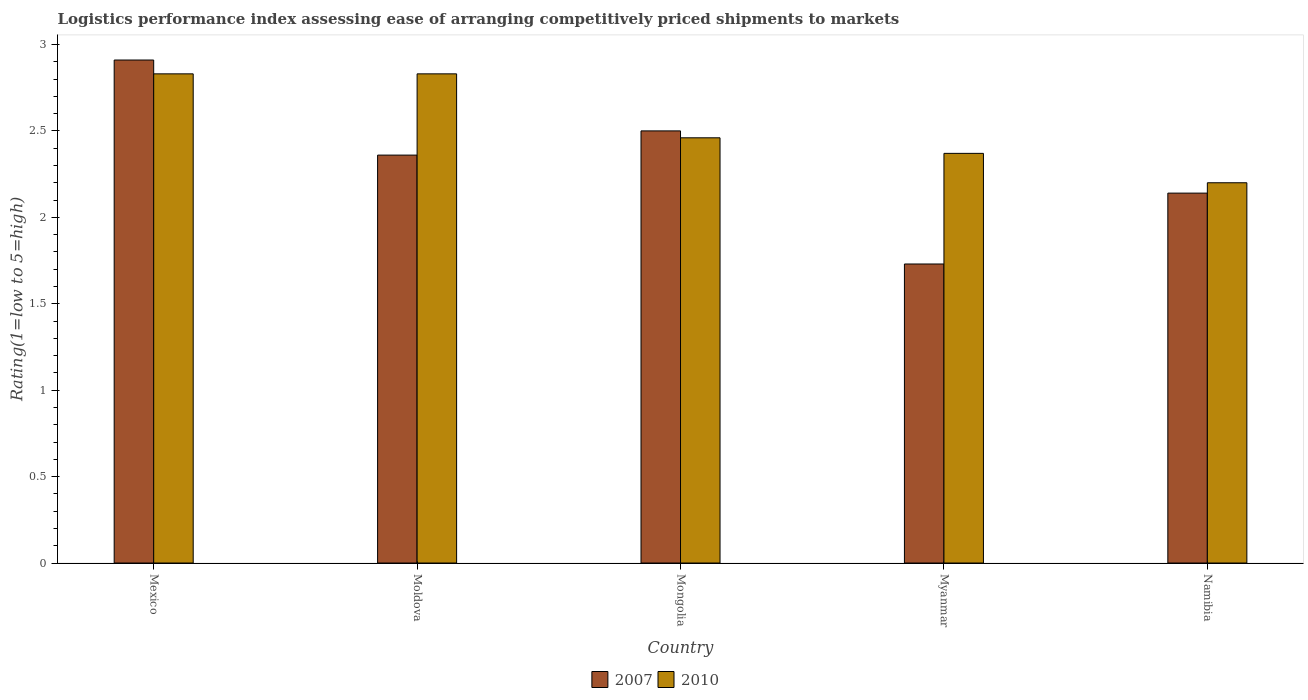How many groups of bars are there?
Give a very brief answer. 5. Are the number of bars per tick equal to the number of legend labels?
Your response must be concise. Yes. What is the label of the 4th group of bars from the left?
Your answer should be very brief. Myanmar. In how many cases, is the number of bars for a given country not equal to the number of legend labels?
Ensure brevity in your answer.  0. Across all countries, what is the maximum Logistic performance index in 2007?
Ensure brevity in your answer.  2.91. Across all countries, what is the minimum Logistic performance index in 2007?
Make the answer very short. 1.73. In which country was the Logistic performance index in 2010 minimum?
Provide a short and direct response. Namibia. What is the total Logistic performance index in 2007 in the graph?
Offer a very short reply. 11.64. What is the difference between the Logistic performance index in 2010 in Mongolia and that in Myanmar?
Keep it short and to the point. 0.09. What is the difference between the Logistic performance index in 2007 in Moldova and the Logistic performance index in 2010 in Namibia?
Ensure brevity in your answer.  0.16. What is the average Logistic performance index in 2007 per country?
Make the answer very short. 2.33. What is the difference between the Logistic performance index of/in 2010 and Logistic performance index of/in 2007 in Mongolia?
Keep it short and to the point. -0.04. In how many countries, is the Logistic performance index in 2010 greater than 2.2?
Keep it short and to the point. 4. What is the ratio of the Logistic performance index in 2007 in Moldova to that in Mongolia?
Give a very brief answer. 0.94. What is the difference between the highest and the second highest Logistic performance index in 2010?
Your response must be concise. 0.37. What is the difference between the highest and the lowest Logistic performance index in 2010?
Make the answer very short. 0.63. In how many countries, is the Logistic performance index in 2010 greater than the average Logistic performance index in 2010 taken over all countries?
Offer a terse response. 2. Is the sum of the Logistic performance index in 2007 in Mexico and Myanmar greater than the maximum Logistic performance index in 2010 across all countries?
Offer a very short reply. Yes. What does the 2nd bar from the right in Mexico represents?
Give a very brief answer. 2007. How many bars are there?
Offer a very short reply. 10. Are all the bars in the graph horizontal?
Make the answer very short. No. How many countries are there in the graph?
Provide a succinct answer. 5. Does the graph contain any zero values?
Your response must be concise. No. How many legend labels are there?
Your response must be concise. 2. How are the legend labels stacked?
Your response must be concise. Horizontal. What is the title of the graph?
Provide a succinct answer. Logistics performance index assessing ease of arranging competitively priced shipments to markets. Does "2008" appear as one of the legend labels in the graph?
Your answer should be very brief. No. What is the label or title of the X-axis?
Your answer should be compact. Country. What is the label or title of the Y-axis?
Ensure brevity in your answer.  Rating(1=low to 5=high). What is the Rating(1=low to 5=high) of 2007 in Mexico?
Make the answer very short. 2.91. What is the Rating(1=low to 5=high) in 2010 in Mexico?
Offer a very short reply. 2.83. What is the Rating(1=low to 5=high) of 2007 in Moldova?
Your answer should be compact. 2.36. What is the Rating(1=low to 5=high) in 2010 in Moldova?
Ensure brevity in your answer.  2.83. What is the Rating(1=low to 5=high) of 2007 in Mongolia?
Give a very brief answer. 2.5. What is the Rating(1=low to 5=high) of 2010 in Mongolia?
Make the answer very short. 2.46. What is the Rating(1=low to 5=high) in 2007 in Myanmar?
Offer a very short reply. 1.73. What is the Rating(1=low to 5=high) in 2010 in Myanmar?
Offer a very short reply. 2.37. What is the Rating(1=low to 5=high) of 2007 in Namibia?
Your response must be concise. 2.14. What is the Rating(1=low to 5=high) in 2010 in Namibia?
Give a very brief answer. 2.2. Across all countries, what is the maximum Rating(1=low to 5=high) of 2007?
Provide a short and direct response. 2.91. Across all countries, what is the maximum Rating(1=low to 5=high) of 2010?
Offer a very short reply. 2.83. Across all countries, what is the minimum Rating(1=low to 5=high) of 2007?
Ensure brevity in your answer.  1.73. What is the total Rating(1=low to 5=high) of 2007 in the graph?
Provide a short and direct response. 11.64. What is the total Rating(1=low to 5=high) of 2010 in the graph?
Offer a very short reply. 12.69. What is the difference between the Rating(1=low to 5=high) of 2007 in Mexico and that in Moldova?
Your answer should be compact. 0.55. What is the difference between the Rating(1=low to 5=high) of 2010 in Mexico and that in Moldova?
Offer a very short reply. 0. What is the difference between the Rating(1=low to 5=high) of 2007 in Mexico and that in Mongolia?
Make the answer very short. 0.41. What is the difference between the Rating(1=low to 5=high) of 2010 in Mexico and that in Mongolia?
Offer a terse response. 0.37. What is the difference between the Rating(1=low to 5=high) of 2007 in Mexico and that in Myanmar?
Offer a terse response. 1.18. What is the difference between the Rating(1=low to 5=high) in 2010 in Mexico and that in Myanmar?
Keep it short and to the point. 0.46. What is the difference between the Rating(1=low to 5=high) in 2007 in Mexico and that in Namibia?
Ensure brevity in your answer.  0.77. What is the difference between the Rating(1=low to 5=high) in 2010 in Mexico and that in Namibia?
Ensure brevity in your answer.  0.63. What is the difference between the Rating(1=low to 5=high) in 2007 in Moldova and that in Mongolia?
Offer a terse response. -0.14. What is the difference between the Rating(1=low to 5=high) in 2010 in Moldova and that in Mongolia?
Keep it short and to the point. 0.37. What is the difference between the Rating(1=low to 5=high) of 2007 in Moldova and that in Myanmar?
Your response must be concise. 0.63. What is the difference between the Rating(1=low to 5=high) in 2010 in Moldova and that in Myanmar?
Provide a succinct answer. 0.46. What is the difference between the Rating(1=low to 5=high) of 2007 in Moldova and that in Namibia?
Your answer should be compact. 0.22. What is the difference between the Rating(1=low to 5=high) of 2010 in Moldova and that in Namibia?
Your answer should be compact. 0.63. What is the difference between the Rating(1=low to 5=high) in 2007 in Mongolia and that in Myanmar?
Ensure brevity in your answer.  0.77. What is the difference between the Rating(1=low to 5=high) of 2010 in Mongolia and that in Myanmar?
Your answer should be very brief. 0.09. What is the difference between the Rating(1=low to 5=high) of 2007 in Mongolia and that in Namibia?
Your answer should be compact. 0.36. What is the difference between the Rating(1=low to 5=high) of 2010 in Mongolia and that in Namibia?
Give a very brief answer. 0.26. What is the difference between the Rating(1=low to 5=high) in 2007 in Myanmar and that in Namibia?
Your answer should be compact. -0.41. What is the difference between the Rating(1=low to 5=high) in 2010 in Myanmar and that in Namibia?
Provide a short and direct response. 0.17. What is the difference between the Rating(1=low to 5=high) in 2007 in Mexico and the Rating(1=low to 5=high) in 2010 in Moldova?
Give a very brief answer. 0.08. What is the difference between the Rating(1=low to 5=high) in 2007 in Mexico and the Rating(1=low to 5=high) in 2010 in Mongolia?
Your answer should be very brief. 0.45. What is the difference between the Rating(1=low to 5=high) of 2007 in Mexico and the Rating(1=low to 5=high) of 2010 in Myanmar?
Keep it short and to the point. 0.54. What is the difference between the Rating(1=low to 5=high) in 2007 in Mexico and the Rating(1=low to 5=high) in 2010 in Namibia?
Give a very brief answer. 0.71. What is the difference between the Rating(1=low to 5=high) of 2007 in Moldova and the Rating(1=low to 5=high) of 2010 in Mongolia?
Your answer should be very brief. -0.1. What is the difference between the Rating(1=low to 5=high) in 2007 in Moldova and the Rating(1=low to 5=high) in 2010 in Myanmar?
Make the answer very short. -0.01. What is the difference between the Rating(1=low to 5=high) of 2007 in Moldova and the Rating(1=low to 5=high) of 2010 in Namibia?
Keep it short and to the point. 0.16. What is the difference between the Rating(1=low to 5=high) in 2007 in Mongolia and the Rating(1=low to 5=high) in 2010 in Myanmar?
Provide a succinct answer. 0.13. What is the difference between the Rating(1=low to 5=high) in 2007 in Mongolia and the Rating(1=low to 5=high) in 2010 in Namibia?
Ensure brevity in your answer.  0.3. What is the difference between the Rating(1=low to 5=high) in 2007 in Myanmar and the Rating(1=low to 5=high) in 2010 in Namibia?
Ensure brevity in your answer.  -0.47. What is the average Rating(1=low to 5=high) in 2007 per country?
Your answer should be compact. 2.33. What is the average Rating(1=low to 5=high) in 2010 per country?
Provide a succinct answer. 2.54. What is the difference between the Rating(1=low to 5=high) of 2007 and Rating(1=low to 5=high) of 2010 in Mexico?
Give a very brief answer. 0.08. What is the difference between the Rating(1=low to 5=high) in 2007 and Rating(1=low to 5=high) in 2010 in Moldova?
Provide a succinct answer. -0.47. What is the difference between the Rating(1=low to 5=high) of 2007 and Rating(1=low to 5=high) of 2010 in Mongolia?
Provide a short and direct response. 0.04. What is the difference between the Rating(1=low to 5=high) of 2007 and Rating(1=low to 5=high) of 2010 in Myanmar?
Your answer should be very brief. -0.64. What is the difference between the Rating(1=low to 5=high) in 2007 and Rating(1=low to 5=high) in 2010 in Namibia?
Make the answer very short. -0.06. What is the ratio of the Rating(1=low to 5=high) in 2007 in Mexico to that in Moldova?
Offer a terse response. 1.23. What is the ratio of the Rating(1=low to 5=high) of 2007 in Mexico to that in Mongolia?
Ensure brevity in your answer.  1.16. What is the ratio of the Rating(1=low to 5=high) of 2010 in Mexico to that in Mongolia?
Provide a succinct answer. 1.15. What is the ratio of the Rating(1=low to 5=high) of 2007 in Mexico to that in Myanmar?
Keep it short and to the point. 1.68. What is the ratio of the Rating(1=low to 5=high) in 2010 in Mexico to that in Myanmar?
Offer a very short reply. 1.19. What is the ratio of the Rating(1=low to 5=high) of 2007 in Mexico to that in Namibia?
Your response must be concise. 1.36. What is the ratio of the Rating(1=low to 5=high) in 2010 in Mexico to that in Namibia?
Keep it short and to the point. 1.29. What is the ratio of the Rating(1=low to 5=high) of 2007 in Moldova to that in Mongolia?
Keep it short and to the point. 0.94. What is the ratio of the Rating(1=low to 5=high) in 2010 in Moldova to that in Mongolia?
Offer a terse response. 1.15. What is the ratio of the Rating(1=low to 5=high) in 2007 in Moldova to that in Myanmar?
Make the answer very short. 1.36. What is the ratio of the Rating(1=low to 5=high) in 2010 in Moldova to that in Myanmar?
Your answer should be compact. 1.19. What is the ratio of the Rating(1=low to 5=high) of 2007 in Moldova to that in Namibia?
Make the answer very short. 1.1. What is the ratio of the Rating(1=low to 5=high) of 2010 in Moldova to that in Namibia?
Provide a short and direct response. 1.29. What is the ratio of the Rating(1=low to 5=high) of 2007 in Mongolia to that in Myanmar?
Your response must be concise. 1.45. What is the ratio of the Rating(1=low to 5=high) of 2010 in Mongolia to that in Myanmar?
Ensure brevity in your answer.  1.04. What is the ratio of the Rating(1=low to 5=high) in 2007 in Mongolia to that in Namibia?
Offer a terse response. 1.17. What is the ratio of the Rating(1=low to 5=high) in 2010 in Mongolia to that in Namibia?
Give a very brief answer. 1.12. What is the ratio of the Rating(1=low to 5=high) of 2007 in Myanmar to that in Namibia?
Provide a succinct answer. 0.81. What is the ratio of the Rating(1=low to 5=high) of 2010 in Myanmar to that in Namibia?
Offer a terse response. 1.08. What is the difference between the highest and the second highest Rating(1=low to 5=high) in 2007?
Your response must be concise. 0.41. What is the difference between the highest and the lowest Rating(1=low to 5=high) in 2007?
Your answer should be compact. 1.18. What is the difference between the highest and the lowest Rating(1=low to 5=high) in 2010?
Provide a short and direct response. 0.63. 